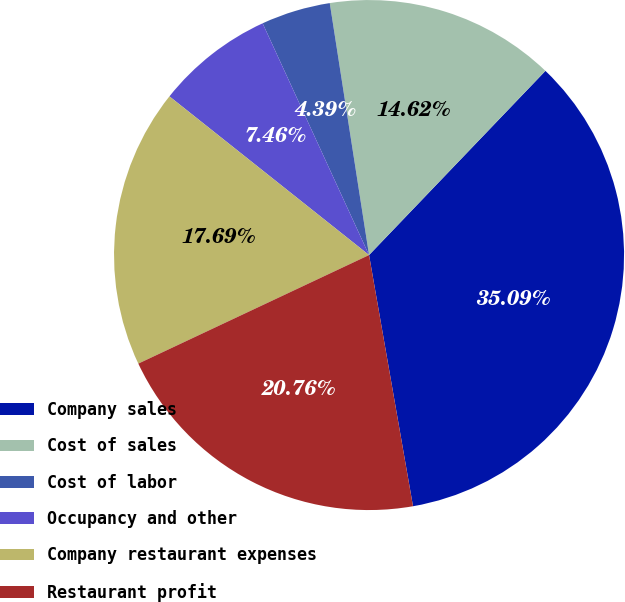Convert chart. <chart><loc_0><loc_0><loc_500><loc_500><pie_chart><fcel>Company sales<fcel>Cost of sales<fcel>Cost of labor<fcel>Occupancy and other<fcel>Company restaurant expenses<fcel>Restaurant profit<nl><fcel>35.09%<fcel>14.62%<fcel>4.39%<fcel>7.46%<fcel>17.69%<fcel>20.76%<nl></chart> 